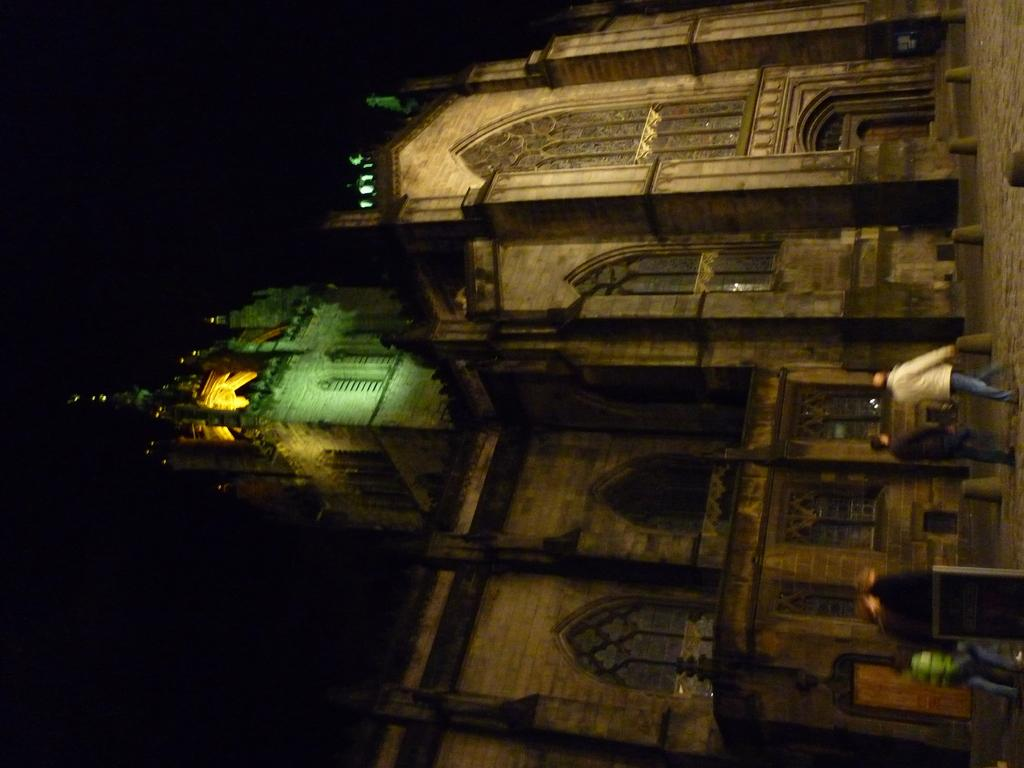What is the main subject of the image? The main subject of the image is a building. What can be seen on the right side of the image? There are people walking on the right side of the image. How would you describe the lighting in the image? The background of the image is dark. What type of tree is being used for learning in the image? There is no tree or learning activity present in the image. Can you tell me which actor is featured in the image? There is no actor present in the image; it features a building and people walking. 